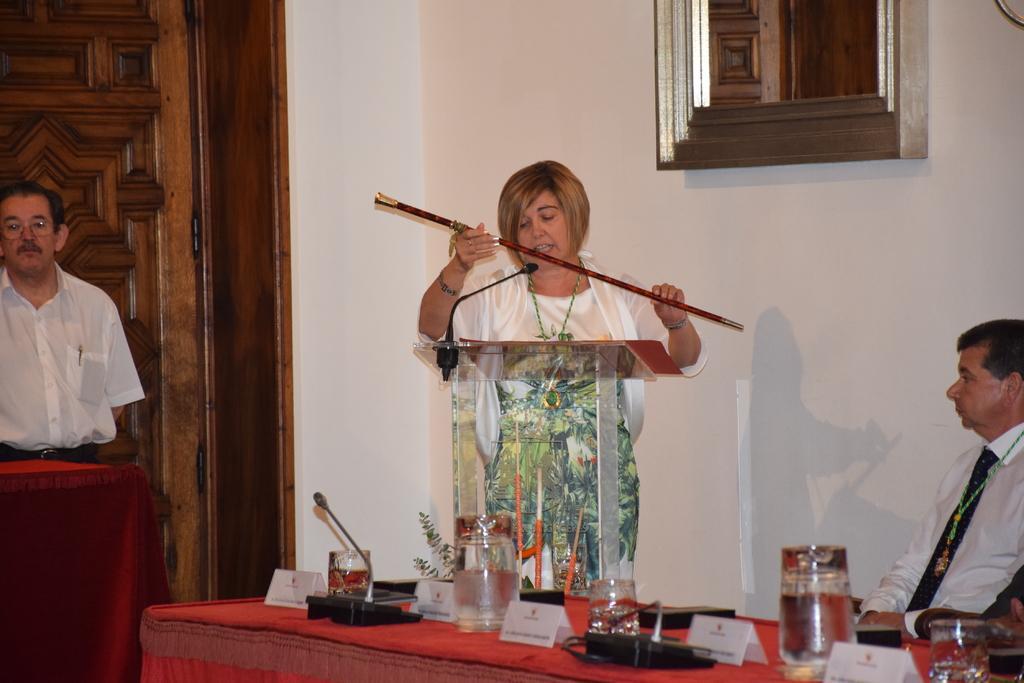In one or two sentences, can you explain what this image depicts? This picture shows a woman holding a stick and speaking in front of a microphone, near the podium. There is a man sitting beside her. In front of him there is a table on which some glass jars and name plates were placed. In the background there is a man, door and a wall here. 